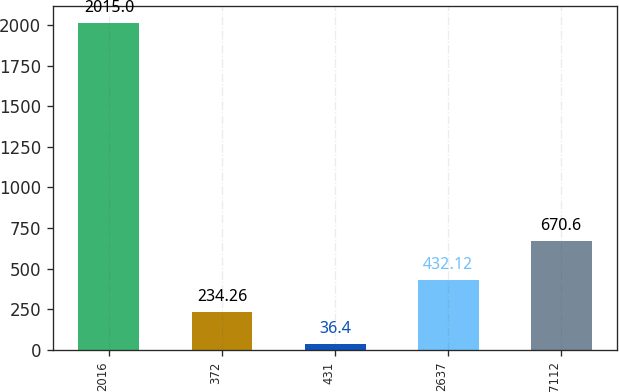<chart> <loc_0><loc_0><loc_500><loc_500><bar_chart><fcel>2016<fcel>372<fcel>431<fcel>2637<fcel>7112<nl><fcel>2015<fcel>234.26<fcel>36.4<fcel>432.12<fcel>670.6<nl></chart> 